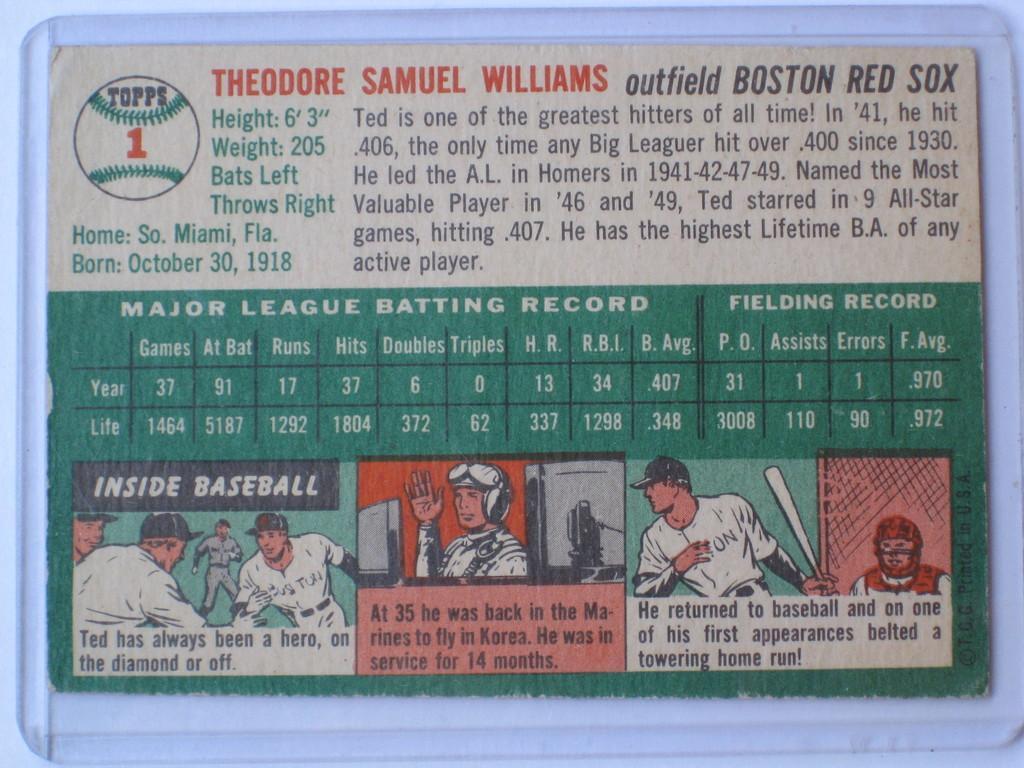In one or two sentences, can you explain what this image depicts? This image consists of a board which is attached to the wall. On the board, I can see some text and few images of persons. 